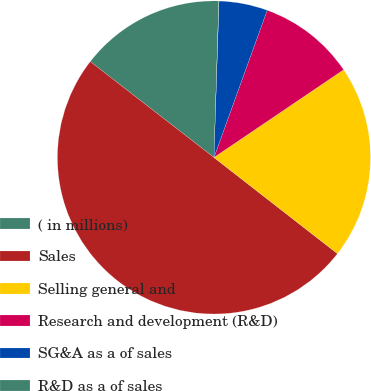Convert chart. <chart><loc_0><loc_0><loc_500><loc_500><pie_chart><fcel>( in millions)<fcel>Sales<fcel>Selling general and<fcel>Research and development (R&D)<fcel>SG&A as a of sales<fcel>R&D as a of sales<nl><fcel>15.0%<fcel>49.97%<fcel>20.0%<fcel>10.01%<fcel>5.01%<fcel>0.02%<nl></chart> 